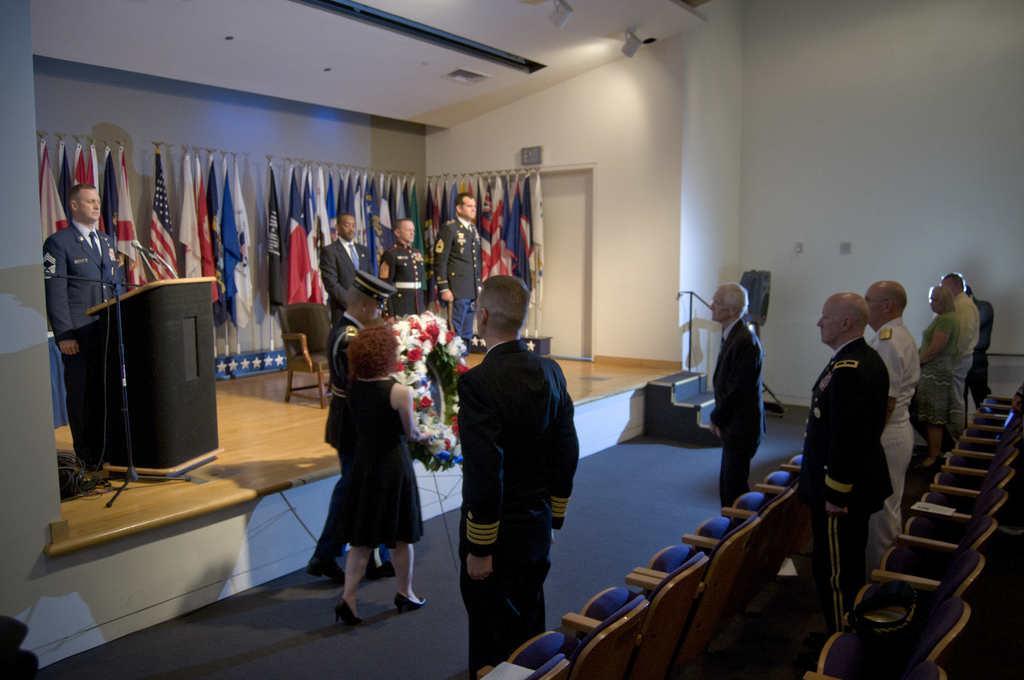Could you give a brief overview of what you see in this image? In this image I can see group of people standing and I can see the person standing in front of the podium and I can see few microphones. In the background I can see few flags in multi color and the wall is in white color. 